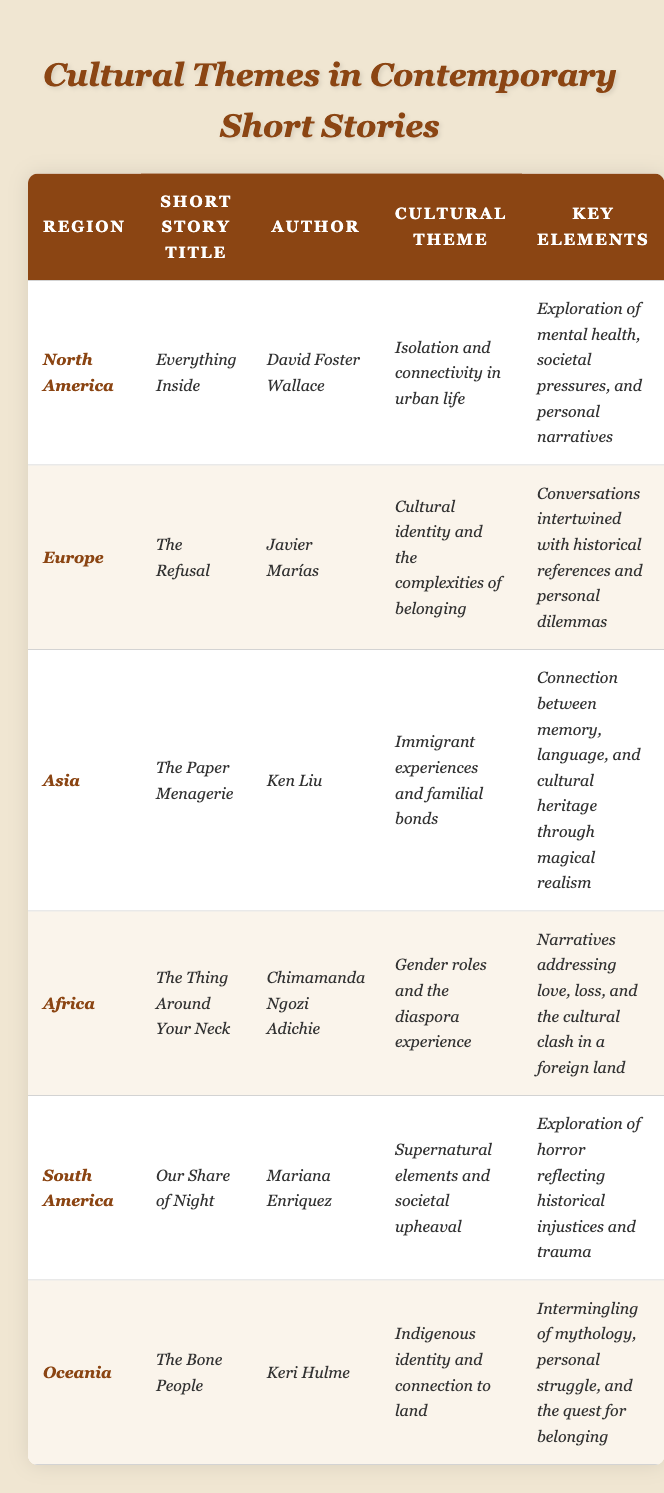What is the cultural theme of the short story "The Bone People"? The table lists "Indigenous identity and connection to land" as the cultural theme for "The Bone People" by Keri Hulme.
Answer: Indigenous identity and connection to land Which author wrote "Our Share of Night"? The table indicates that "Our Share of Night" was written by Mariana Enriquez.
Answer: Mariana Enriquez From which region is the short story "The Paper Menagerie"? The table shows that "The Paper Menagerie" is from the region of Asia.
Answer: Asia How many short stories listed have the cultural theme of gender roles? The data indicates that only one short story, "The Thing Around Your Neck," has the cultural theme of gender roles, which is by Chimamanda Ngozi Adichie.
Answer: 1 Who is the author associated with the theme of cultural identity and the complexities of belonging? According to the table, Javier Marías is the author associated with this theme in "The Refusal."
Answer: Javier Marías Is "Everything Inside" about societal pressures? Yes, the cultural theme mentioned for "Everything Inside" includes societal pressures along with isolation and connectivity in urban life.
Answer: Yes Which region's stories explore the theme of supernatural elements? The table shows that "Our Share of Night," which explores supernatural elements, comes from South America.
Answer: South America What are the key elements highlighted in "The Thing Around Your Neck"? The key elements listed for "The Thing Around Your Neck" involve narratives of love, loss, and cultural clashes in a foreign land.
Answer: Love, loss, and cultural clashes Among the stories, which one addresses mental health issues? "Everything Inside" by David Foster Wallace focuses on mental health issues as indicated in the key elements.
Answer: Everything Inside Compare the key elements of "The Bone People" and "The Paper Menagerie". What similarities can be found? Both stories deal with identity, connection, and struggle, with "The Bone People" exploring indigenous identity linked to land and "The Paper Menagerie" focusing on cultural heritage and familial bonds.
Answer: Identity and connection struggles What is the relationship between the authors of stories that focus on themes of belonging and identity? Keri Hulme and Ken Liu both focus on identity in their respective stories—"The Bone People" and "The Paper Menagerie"—linking their themes to cultural and familial experiences of belonging.
Answer: Both focus on identity themes 